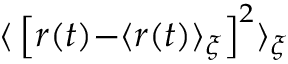<formula> <loc_0><loc_0><loc_500><loc_500>{ \langle } \left [ r ( t ) { - } \langle r ( t ) \rangle _ { \xi } \right ] ^ { 2 } \rangle _ { \xi }</formula> 